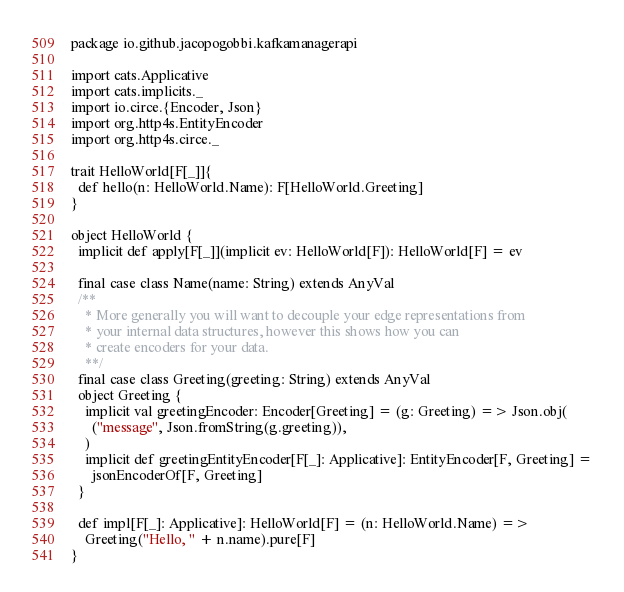Convert code to text. <code><loc_0><loc_0><loc_500><loc_500><_Scala_>package io.github.jacopogobbi.kafkamanagerapi

import cats.Applicative
import cats.implicits._
import io.circe.{Encoder, Json}
import org.http4s.EntityEncoder
import org.http4s.circe._

trait HelloWorld[F[_]]{
  def hello(n: HelloWorld.Name): F[HelloWorld.Greeting]
}

object HelloWorld {
  implicit def apply[F[_]](implicit ev: HelloWorld[F]): HelloWorld[F] = ev

  final case class Name(name: String) extends AnyVal
  /**
    * More generally you will want to decouple your edge representations from
    * your internal data structures, however this shows how you can
    * create encoders for your data.
    **/
  final case class Greeting(greeting: String) extends AnyVal
  object Greeting {
    implicit val greetingEncoder: Encoder[Greeting] = (g: Greeting) => Json.obj(
      ("message", Json.fromString(g.greeting)),
    )
    implicit def greetingEntityEncoder[F[_]: Applicative]: EntityEncoder[F, Greeting] =
      jsonEncoderOf[F, Greeting]
  }

  def impl[F[_]: Applicative]: HelloWorld[F] = (n: HelloWorld.Name) =>
    Greeting("Hello, " + n.name).pure[F]
}</code> 